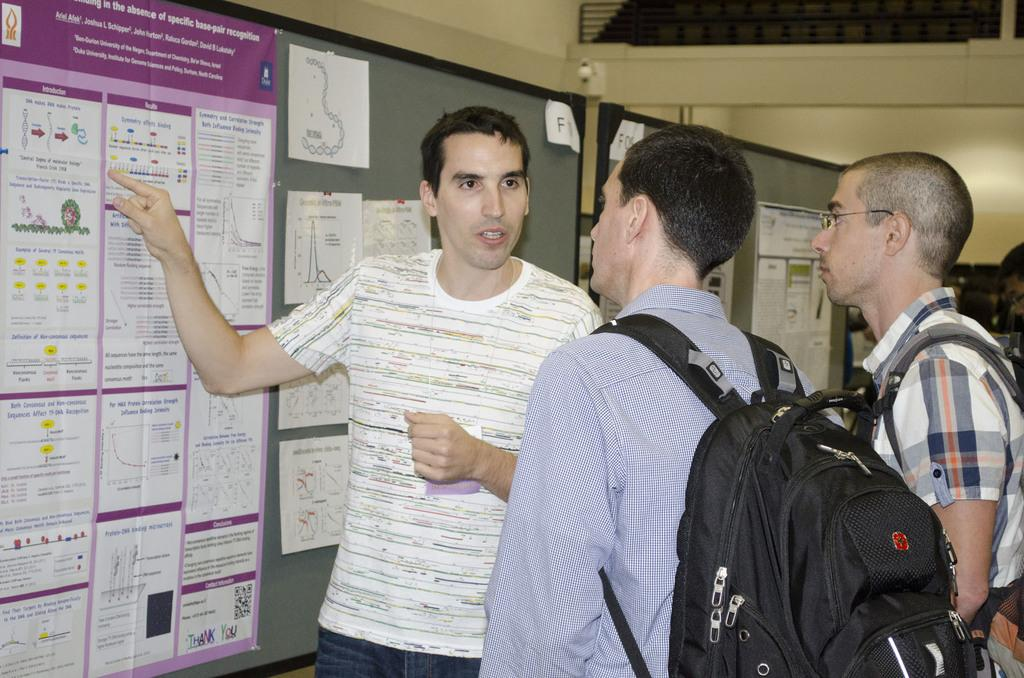<image>
Write a terse but informative summary of the picture. Three guys looking at a bulletin board with the word Introduction on it and one is pointing at it. 